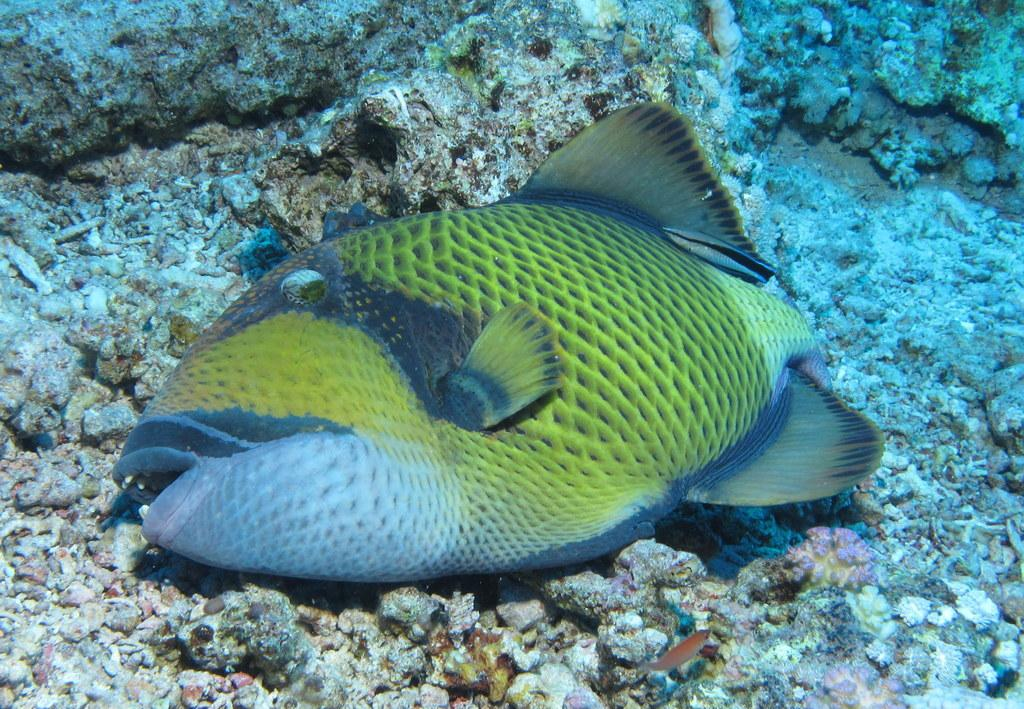What type of animal is in the image? There is a green color fish in the image. What category of animals can be seen in the image? There are marine species in the image. What type of muscle can be seen in the image? There is no muscle visible in the image; it features marine species, including a green color fish. What type of stone is present in the image? There is no stone present in the image; it features marine species in an aquatic environment. 